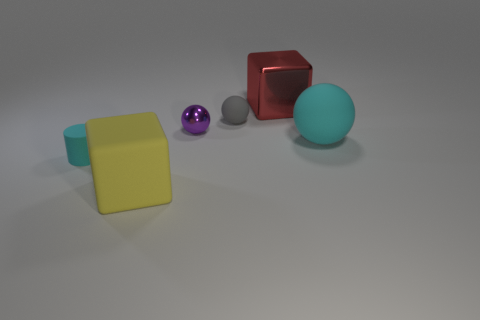Looking at the backdrop, what can you say about the environment these objects are in? The environment seems to be a neutral and nondescript space with a smooth, even floor that softly blends into the background. The lack of distinguishable features or context suggests it might be a controlled setting, such as a photographic studio or a computer-generated simulation. 